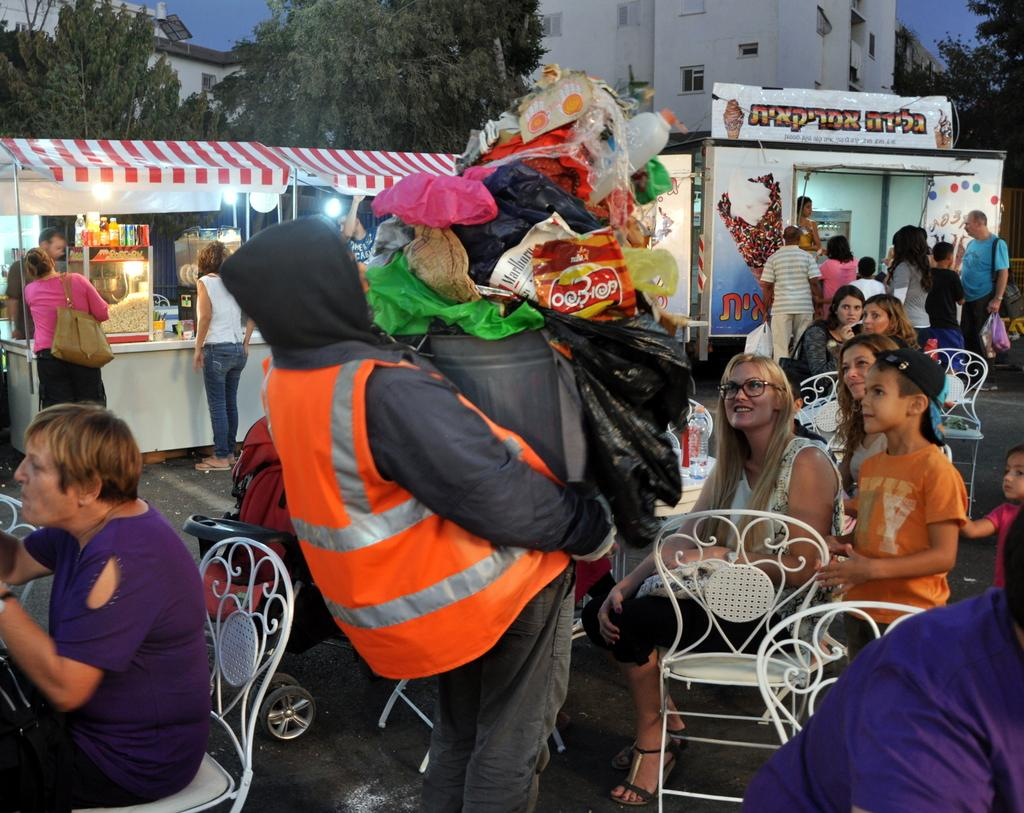What is the man in the image holding? The man is holding a dustbin in the image. What can be seen in the background of the image? There are chairs, persons, stalls, trees, buildings, and the sky visible in the background of the image. What type of kettle is being used to capture the hope in the image? There is no kettle or hope present in the image; it features a man holding a dustbin and various elements in the background. 